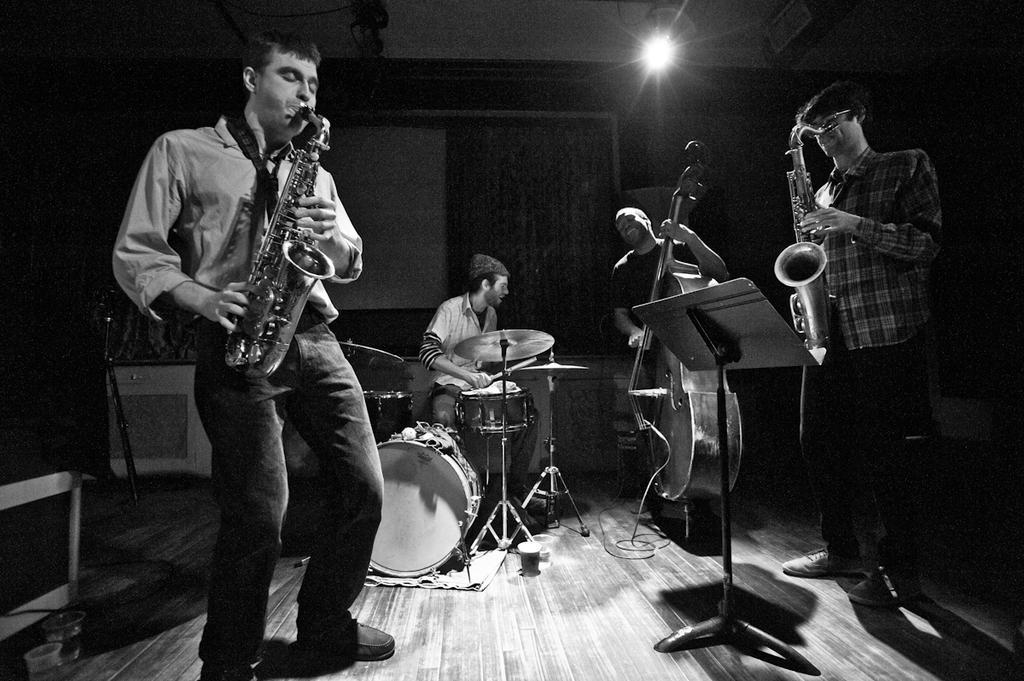Describe this image in one or two sentences. In this image I can see few people playing musical instruments. In the background I can see a light. 